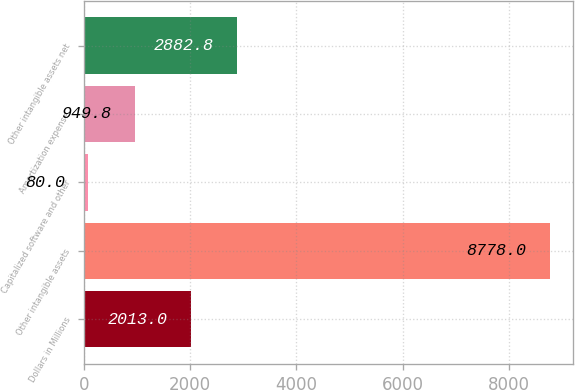Convert chart. <chart><loc_0><loc_0><loc_500><loc_500><bar_chart><fcel>Dollars in Millions<fcel>Other intangible assets<fcel>Capitalized software and other<fcel>Amortization expense<fcel>Other intangible assets net<nl><fcel>2013<fcel>8778<fcel>80<fcel>949.8<fcel>2882.8<nl></chart> 